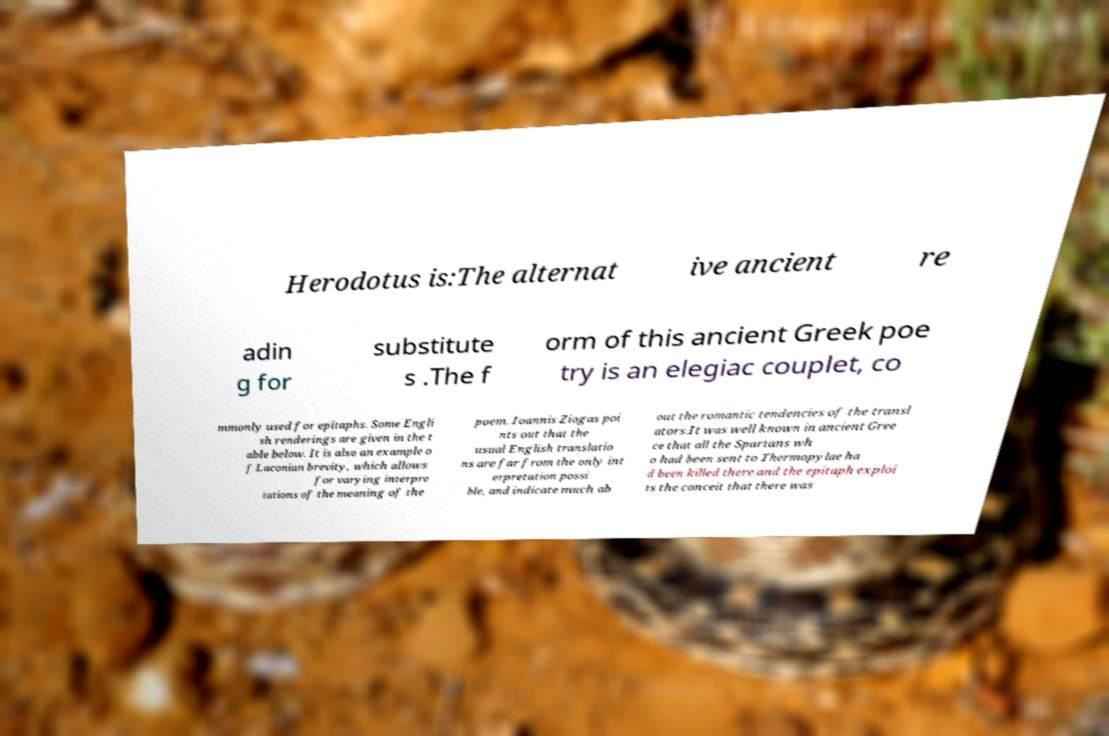I need the written content from this picture converted into text. Can you do that? Herodotus is:The alternat ive ancient re adin g for substitute s .The f orm of this ancient Greek poe try is an elegiac couplet, co mmonly used for epitaphs. Some Engli sh renderings are given in the t able below. It is also an example o f Laconian brevity, which allows for varying interpre tations of the meaning of the poem. Ioannis Ziogas poi nts out that the usual English translatio ns are far from the only int erpretation possi ble, and indicate much ab out the romantic tendencies of the transl ators.It was well known in ancient Gree ce that all the Spartans wh o had been sent to Thermopylae ha d been killed there and the epitaph exploi ts the conceit that there was 